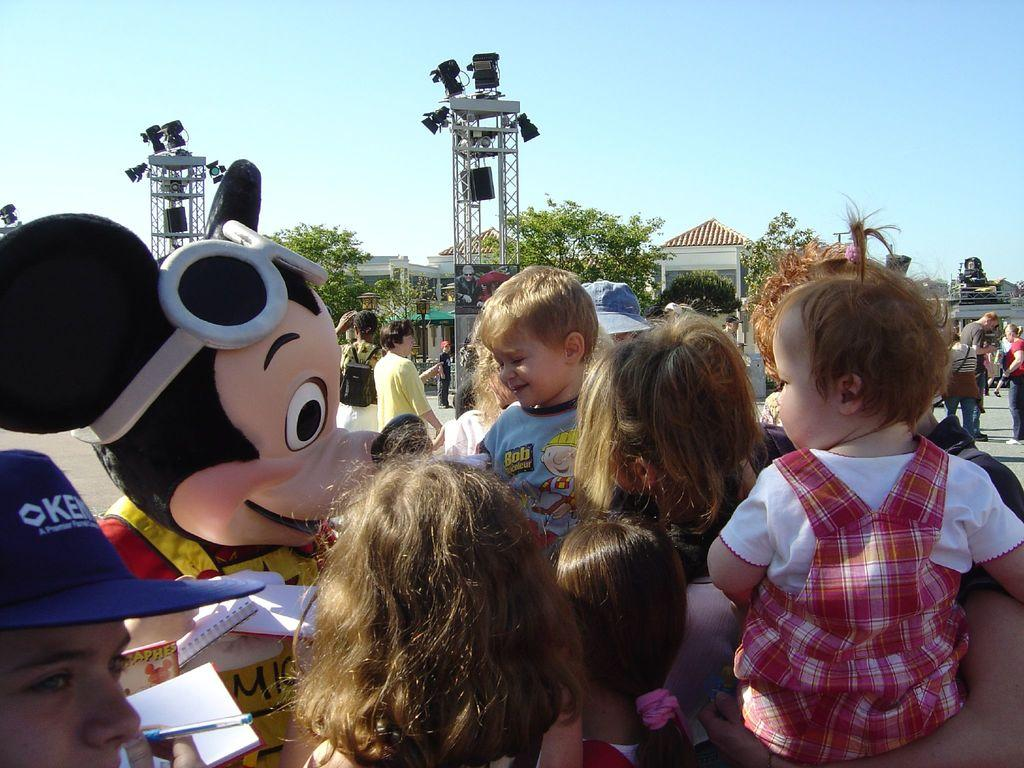What can be seen in the image? There are kids in the image, and they are in front of a clown. What else is present in the image besides the kids and the clown? There are towers and trees in the image, and they are in front of a building. What is visible in the background of the image? The sky is visible in the background of the image. Where is the lunchroom located in the image? There is no lunchroom present in the image. What impulse might the kids be experiencing in the image? It is not possible to determine the kids' emotions or impulses from the image alone. 